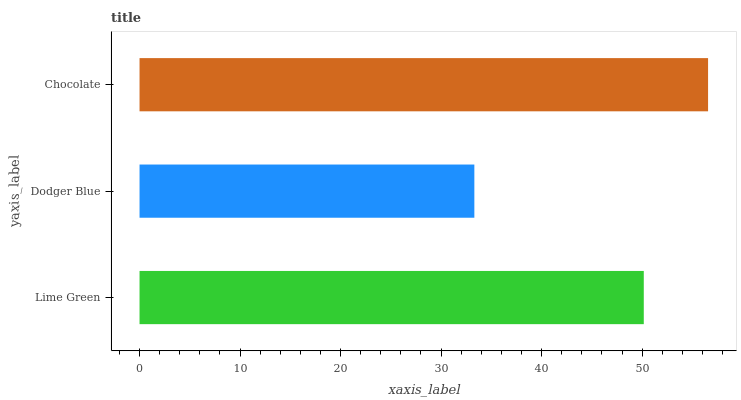Is Dodger Blue the minimum?
Answer yes or no. Yes. Is Chocolate the maximum?
Answer yes or no. Yes. Is Chocolate the minimum?
Answer yes or no. No. Is Dodger Blue the maximum?
Answer yes or no. No. Is Chocolate greater than Dodger Blue?
Answer yes or no. Yes. Is Dodger Blue less than Chocolate?
Answer yes or no. Yes. Is Dodger Blue greater than Chocolate?
Answer yes or no. No. Is Chocolate less than Dodger Blue?
Answer yes or no. No. Is Lime Green the high median?
Answer yes or no. Yes. Is Lime Green the low median?
Answer yes or no. Yes. Is Chocolate the high median?
Answer yes or no. No. Is Dodger Blue the low median?
Answer yes or no. No. 